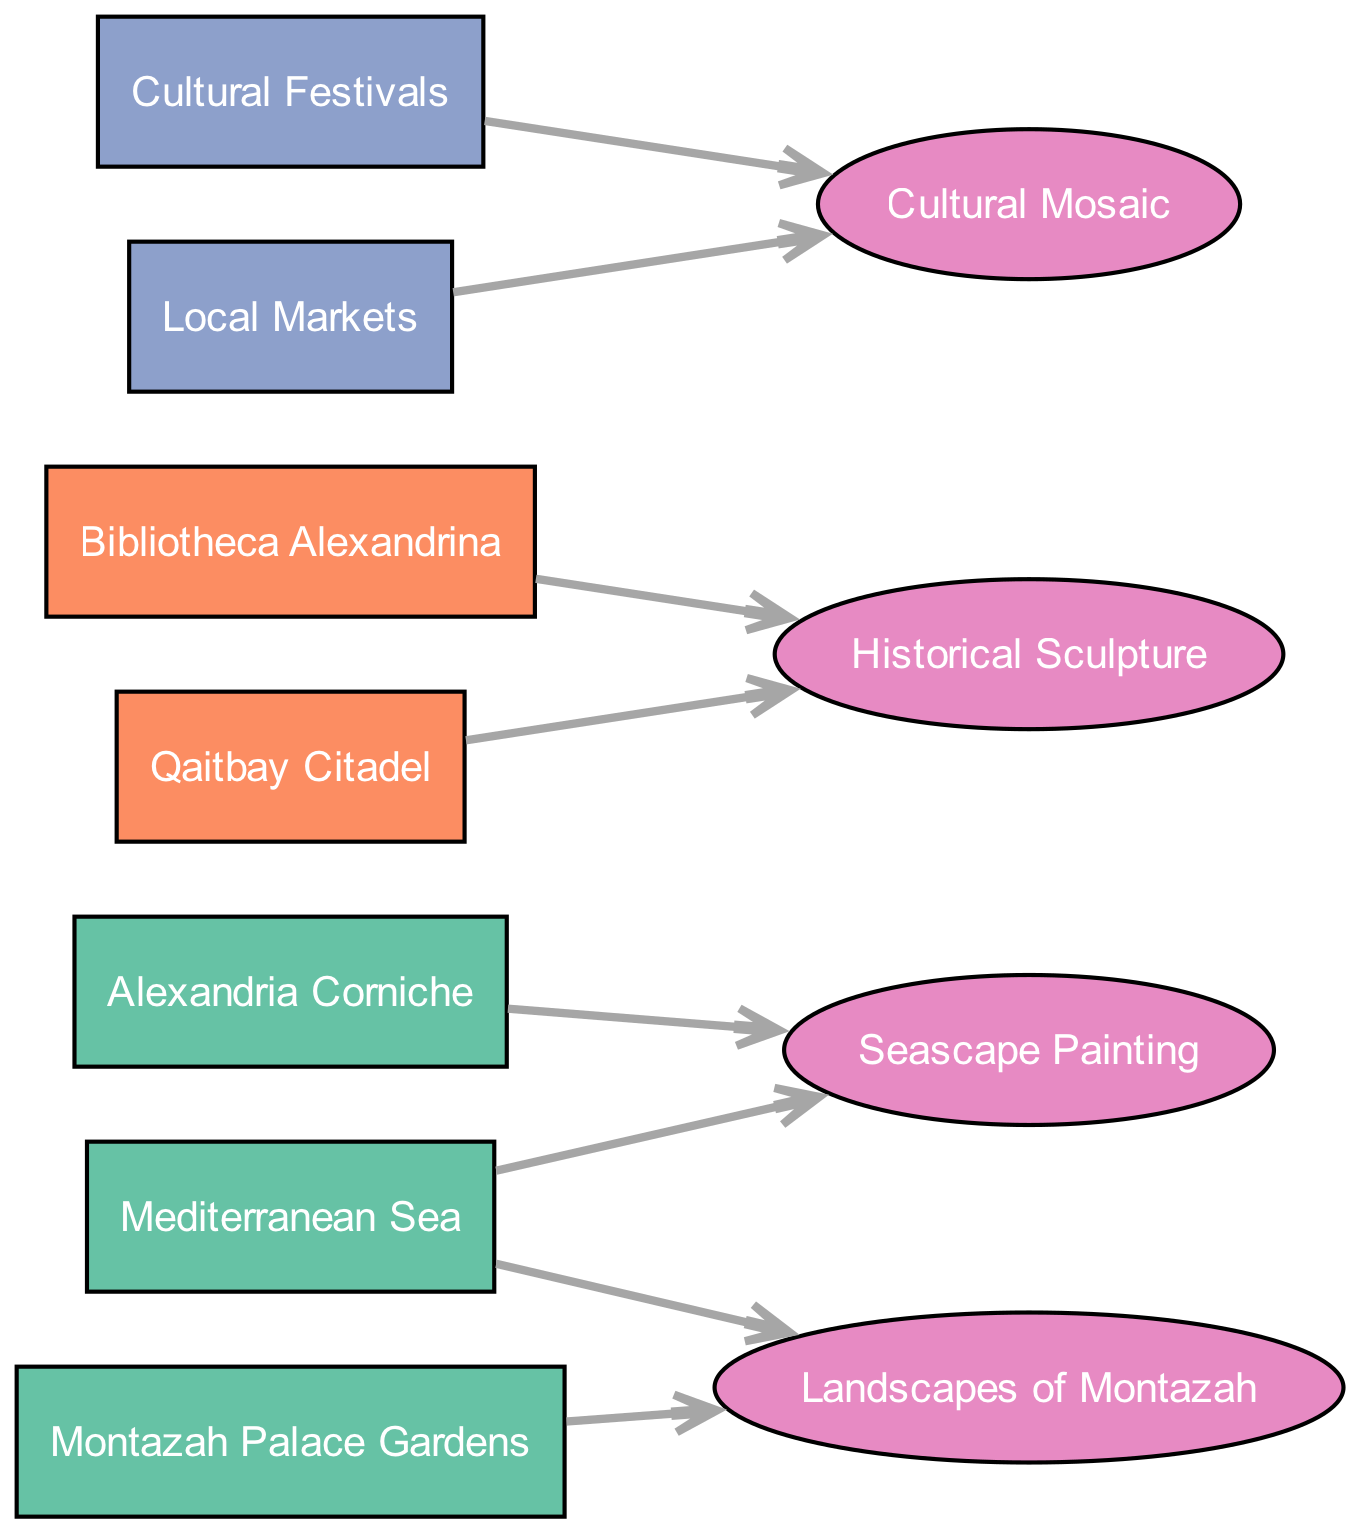What are the local scenery sources depicted in the diagram? The diagram lists three local scenery sources: Mediterranean Sea, Alexandria Corniche, and Montazah Palace Gardens. This information is gathered from the source nodes categorized under 'Local Scenery.'
Answer: Mediterranean Sea, Alexandria Corniche, Montazah Palace Gardens How many artworks are represented in the diagram? The diagram contains four artworks: Seascape Painting, Historical Sculpture, Cultural Mosaic, and Landscapes of Montazah. The count is obtained by identifying the oval nodes corresponding to the artworks.
Answer: 4 Which historical site is linked to the Historical Sculpture artwork? The Historical Sculpture is associated with two historical sites: Bibliotheca Alexandrina and Qaitbay Citadel. This relationship is established by examining the edges connecting the artwork node to its related sources.
Answer: Bibliotheca Alexandrina, Qaitbay Citadel What is the primary source for the Cultural Mosaic artwork? The Cultural Mosaic artwork is linked to two sources: Cultural Festivals and Local Markets. To determine the primary source, we look at the connections leading to the artwork node; both contribute equally.
Answer: Cultural Festivals, Local Markets How many edges lead to the Seascape Painting artwork? The Seascape Painting has two edges leading to it — one from the Mediterranean Sea and another from the Alexandria Corniche. This is ascertained by counting the arrows connecting the source nodes to the Seascape Painting in the diagram.
Answer: 2 Which local scenery source has a connection to the Landscapes of Montazah artwork? The Landscapes of Montazah artwork is connected to two sources: Montazah Palace Gardens and the Mediterranean Sea. By examining the edges for this artwork, both sources are identified as related.
Answer: Montazah Palace Gardens, Mediterranean Sea Which category has the least number of sources depicted in the diagram? There are three categories represented: Local Scenery (3 sources), Historical Sites (2 sources), and Cultural Encounters (2 sources). The category with the least sources is both Historical Sites and Cultural Encounters, each with 2 sources.
Answer: Historical Sites, Cultural Encounters What type of artwork is connected to the Alexandria Corniche? The Alexandria Corniche is associated with the Seascape Painting. This is determined by inspecting the edges leading to and from the Alexandria Corniche source to find its correlating artwork.
Answer: Seascape Painting 